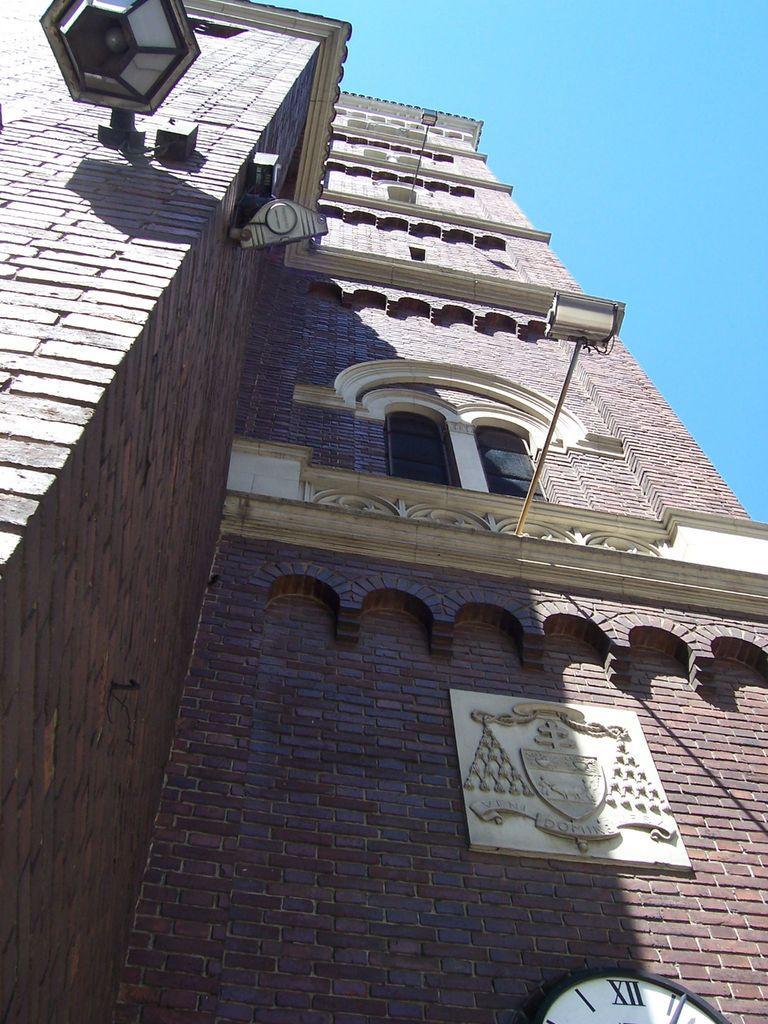Could you give a brief overview of what you see in this image? In the foreground I can see a building wall, window, lamp and a clock is mounted on it. On the top I can see the blue sky. This image is taken during a day. 